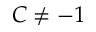Convert formula to latex. <formula><loc_0><loc_0><loc_500><loc_500>C \ne - 1</formula> 